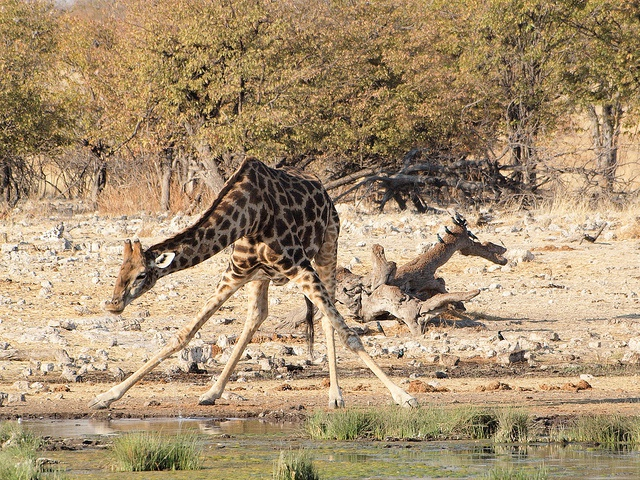Describe the objects in this image and their specific colors. I can see a giraffe in tan, black, and gray tones in this image. 